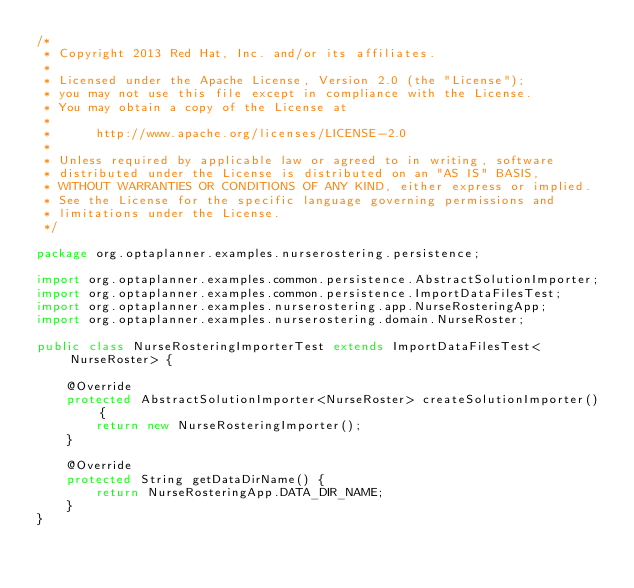<code> <loc_0><loc_0><loc_500><loc_500><_Java_>/*
 * Copyright 2013 Red Hat, Inc. and/or its affiliates.
 *
 * Licensed under the Apache License, Version 2.0 (the "License");
 * you may not use this file except in compliance with the License.
 * You may obtain a copy of the License at
 *
 *      http://www.apache.org/licenses/LICENSE-2.0
 *
 * Unless required by applicable law or agreed to in writing, software
 * distributed under the License is distributed on an "AS IS" BASIS,
 * WITHOUT WARRANTIES OR CONDITIONS OF ANY KIND, either express or implied.
 * See the License for the specific language governing permissions and
 * limitations under the License.
 */

package org.optaplanner.examples.nurserostering.persistence;

import org.optaplanner.examples.common.persistence.AbstractSolutionImporter;
import org.optaplanner.examples.common.persistence.ImportDataFilesTest;
import org.optaplanner.examples.nurserostering.app.NurseRosteringApp;
import org.optaplanner.examples.nurserostering.domain.NurseRoster;

public class NurseRosteringImporterTest extends ImportDataFilesTest<NurseRoster> {

    @Override
    protected AbstractSolutionImporter<NurseRoster> createSolutionImporter() {
        return new NurseRosteringImporter();
    }

    @Override
    protected String getDataDirName() {
        return NurseRosteringApp.DATA_DIR_NAME;
    }
}
</code> 